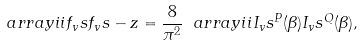Convert formula to latex. <formula><loc_0><loc_0><loc_500><loc_500>\ a r r a y i i { f _ { v } s } { f _ { v } s - z } = \frac { 8 } { \pi ^ { 2 } } \ a r r a y i i { I _ { v } s ^ { P } ( \beta ) } { I _ { v } s ^ { Q } ( \beta ) } ,</formula> 